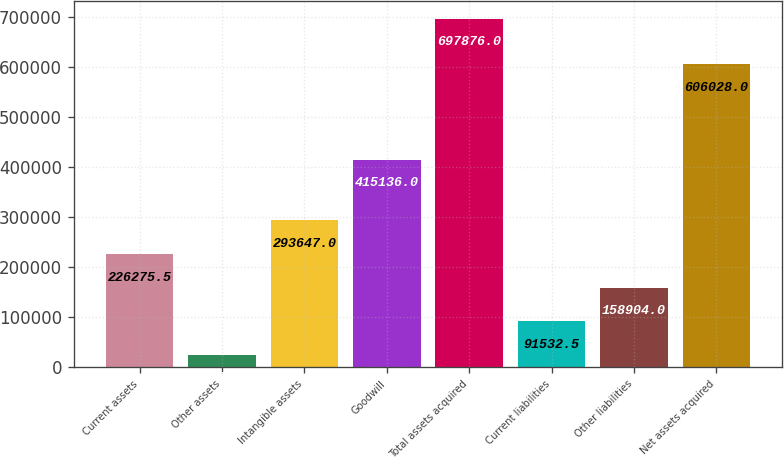Convert chart. <chart><loc_0><loc_0><loc_500><loc_500><bar_chart><fcel>Current assets<fcel>Other assets<fcel>Intangible assets<fcel>Goodwill<fcel>Total assets acquired<fcel>Current liabilities<fcel>Other liabilities<fcel>Net assets acquired<nl><fcel>226276<fcel>24161<fcel>293647<fcel>415136<fcel>697876<fcel>91532.5<fcel>158904<fcel>606028<nl></chart> 